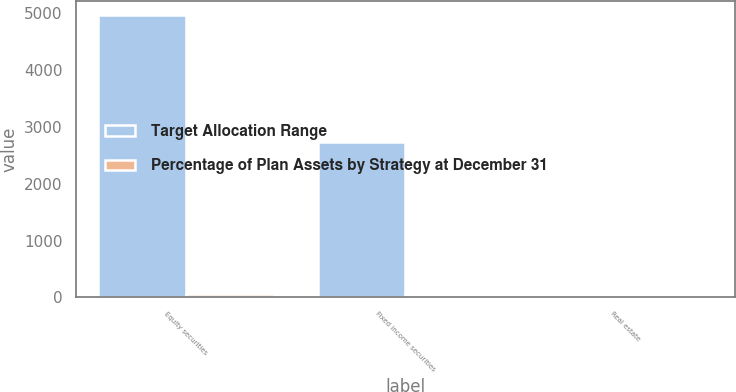Convert chart to OTSL. <chart><loc_0><loc_0><loc_500><loc_500><stacked_bar_chart><ecel><fcel>Equity securities<fcel>Fixed income securities<fcel>Real estate<nl><fcel>Target Allocation Range<fcel>4969<fcel>2741<fcel>8<nl><fcel>Percentage of Plan Assets by Strategy at December 31<fcel>62<fcel>34<fcel>4<nl></chart> 